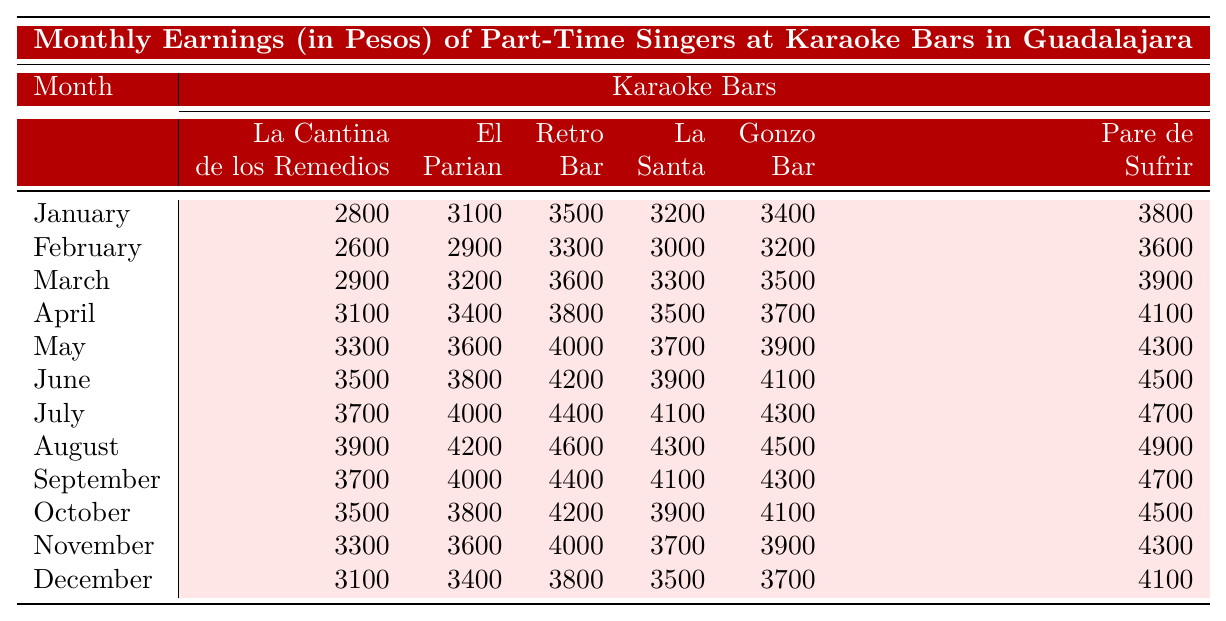What were the earnings of singers at La Cantina de los Remedios in August? In the "January" row, the earnings at La Cantina de los Remedios for August are listed as 3900 pesos.
Answer: 3900 pesos Which month saw the highest earnings at Pare de Sufrir? To find the highest earnings at Pare de Sufrir, I would review the earnings for each month. The maximum value in the Pare de Sufrir column is 4900 pesos in August.
Answer: August What is the total earnings for singers at Retro Bar from January to June? To get the total for Retro Bar from January to June, I sum up the values: 3500 + 3300 + 3600 + 3800 + 4200 + 4500 = 22800.
Answer: 22800 pesos Did singers earn more at Gonzo Bar in December than in January? Comparing the earnings of Gonzo Bar in December (3700 pesos) and January (3400 pesos), December's earnings are higher.
Answer: Yes What is the average monthly earning at El Parian throughout the year? I will calculate the average of El Parian earnings: (3100 + 2900 + 3200 + 3400 + 3600 + 3800 + 4000 + 4200 + 4000 + 3800 + 3600 + 3400) / 12 = 3533.33.
Answer: 3533.33 pesos In which month did the earnings at La Santa reach 3900 pesos for the first time? Reviewing the earnings: La Santa had 3900 pesos in October. That is the first occurrence in the list.
Answer: October What is the difference in earnings between the highest month at Retro Bar and the lowest month? The highest earnings at Retro Bar is 4600 pesos (in August) and the lowest is 3500 pesos (in January), hence the difference is 4600 - 3500 = 1100.
Answer: 1100 pesos Which karaoke bar had the highest average earnings across all months? I will compute the averages, with one sum per karaoke: La Cantina: 3400, El Parian: 3433.33, Retro Bar: 3783.33, La Santa: 3900, Gonzo Bar: 3950, Pare de Sufrir: 4083.33. Pare de Sufrir has the highest average at 4083.33.
Answer: Pare de Sufrir Are the earnings for singers at La Cantina de los Remedios consistently lower than those at Pare de Sufrir? When I compare both columns throughout the year, La Cantina earnings are lower than Pare de Sufrir in every month.
Answer: Yes What are the total earnings for all karaoke bars combined in the month of July? Adding up all the earnings of July: 3700 + 4000 + 4400 + 4100 + 4300 + 4700 = 22200.
Answer: 22200 pesos 